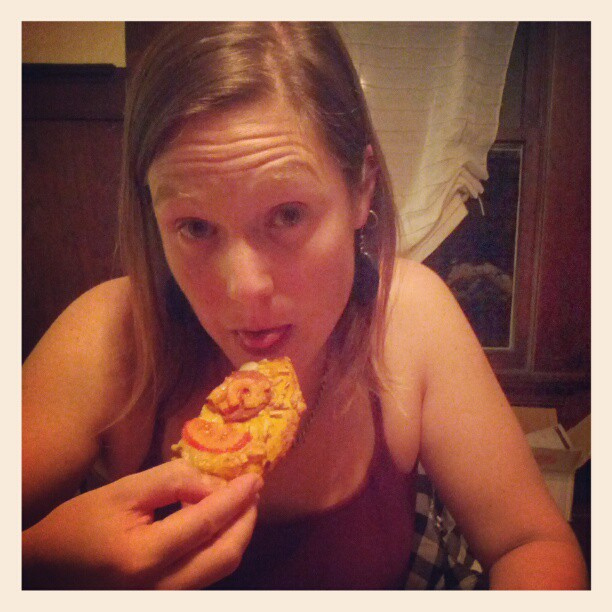<image>What type of pizza is that? I don't know what type of pizza that is. It could be tomato, pepperoni or plain. What type of pizza is that? I don't know what type of pizza that is. It could be tomato, homemade, pepperoni, or plain. 